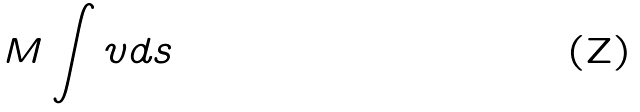<formula> <loc_0><loc_0><loc_500><loc_500>M \int v d s</formula> 